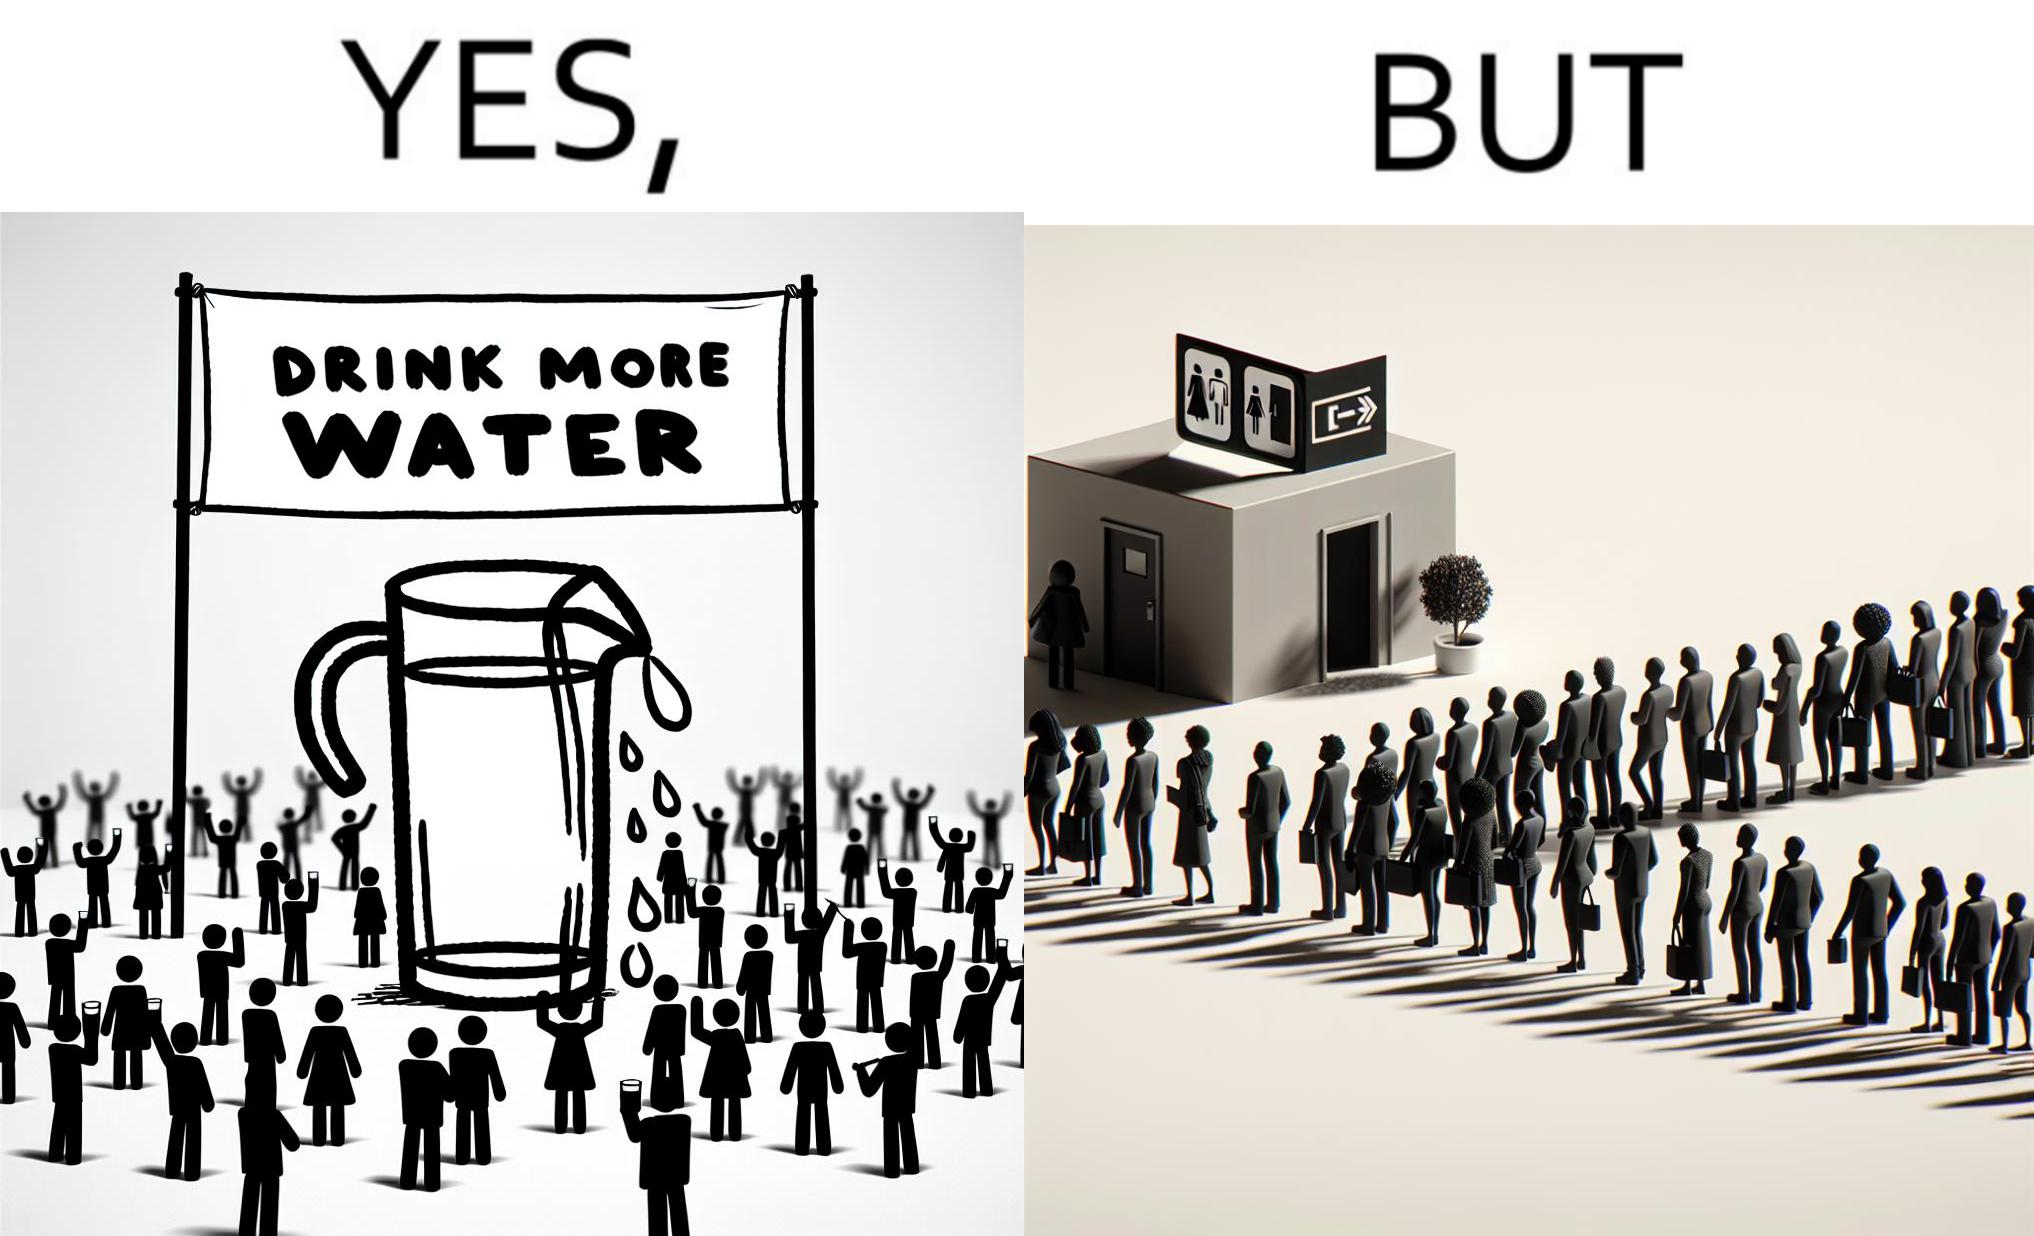Describe the satirical element in this image. The image is ironical, as the message "Drink more water" is meant to improve health, but in turn, it would lead to longer queues in front of public toilets, leading to people holding urine for longer periods, in turn leading to deterioration in health. 